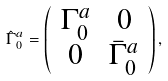<formula> <loc_0><loc_0><loc_500><loc_500>\hat { \Gamma } _ { 0 } ^ { a } = \left ( \begin{array} { c c } \Gamma _ { 0 } ^ { a } & 0 \\ 0 & \bar { \Gamma } _ { 0 } ^ { a } \end{array} \right ) ,</formula> 